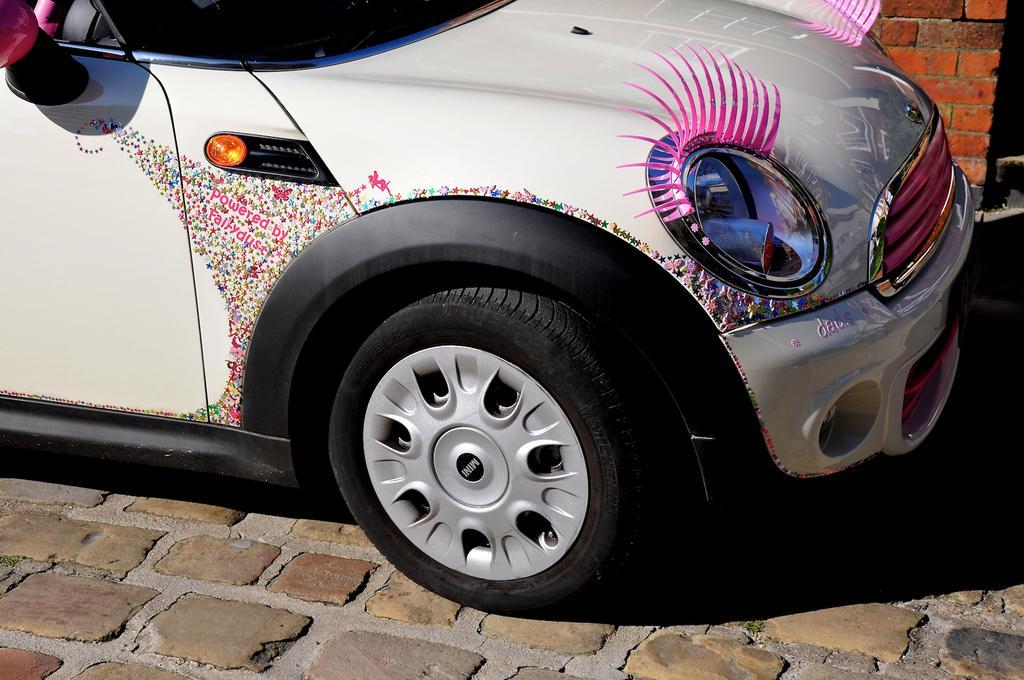Could you give a brief overview of what you see in this image? In this image we can see a vehicle on the surface. And we can see the wall. 